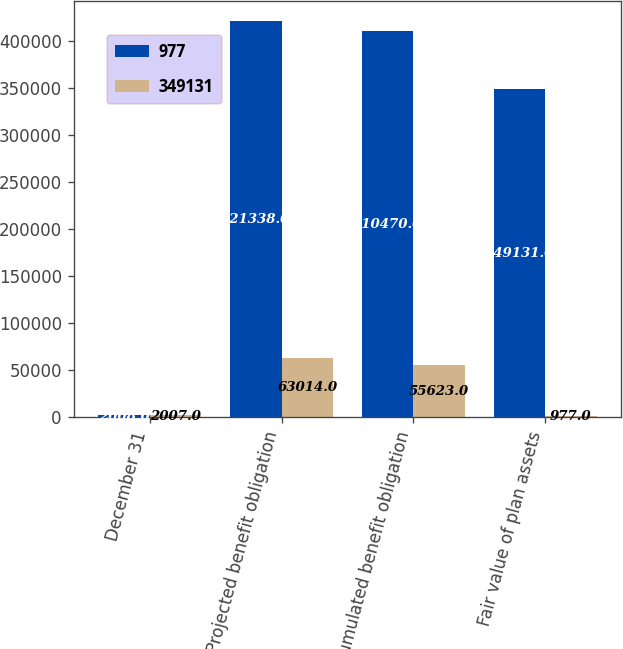<chart> <loc_0><loc_0><loc_500><loc_500><stacked_bar_chart><ecel><fcel>December 31<fcel>Projected benefit obligation<fcel>Accumulated benefit obligation<fcel>Fair value of plan assets<nl><fcel>977<fcel>2008<fcel>421338<fcel>410470<fcel>349131<nl><fcel>349131<fcel>2007<fcel>63014<fcel>55623<fcel>977<nl></chart> 